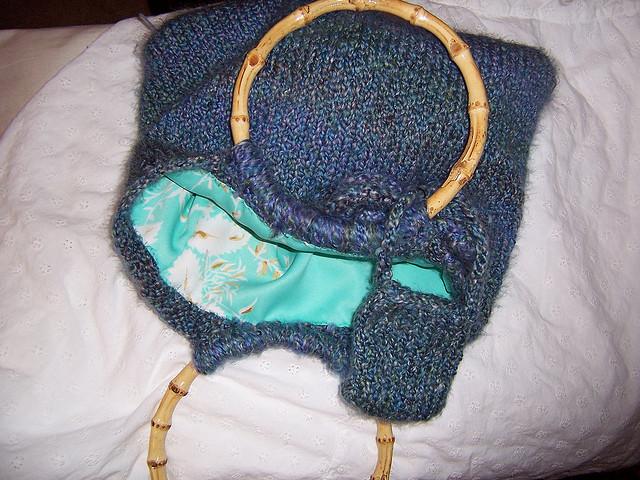Is this handbag haute couture?
Concise answer only. No. What color are the flowers on the handbag?
Answer briefly. White. What material is the handbag?
Keep it brief. Wool. What are the handles made out of?
Be succinct. Bamboo. Is this bag reusable?
Quick response, please. Yes. 